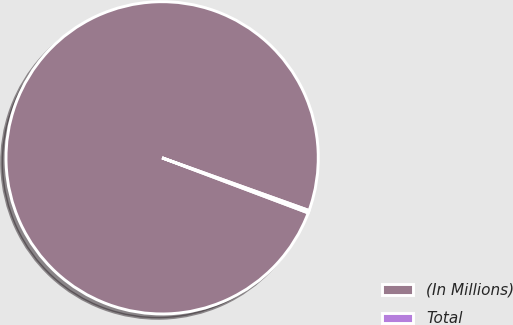Convert chart. <chart><loc_0><loc_0><loc_500><loc_500><pie_chart><fcel>(In Millions)<fcel>Total<nl><fcel>99.74%<fcel>0.26%<nl></chart> 